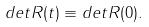Convert formula to latex. <formula><loc_0><loc_0><loc_500><loc_500>d e t R ( t ) \equiv d e t R ( 0 ) .</formula> 